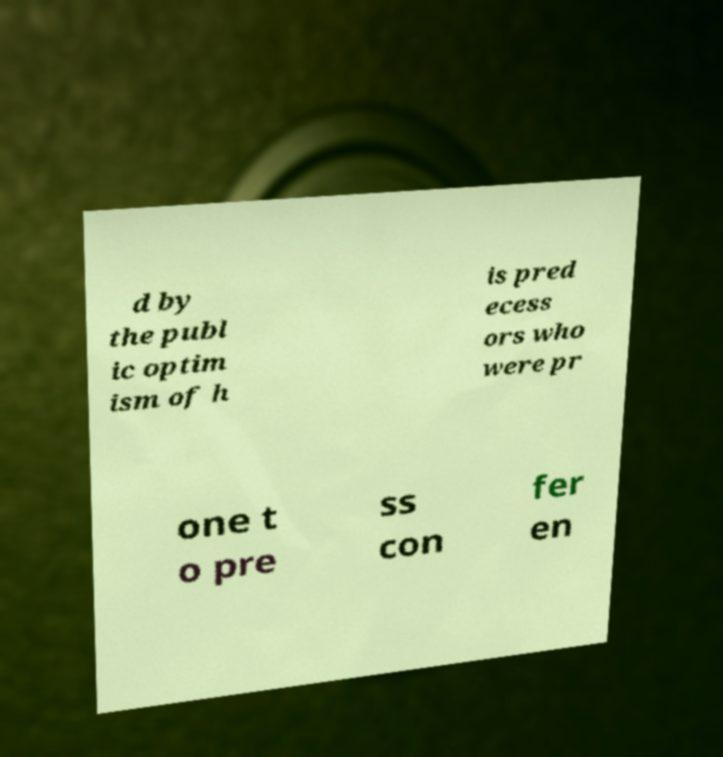I need the written content from this picture converted into text. Can you do that? d by the publ ic optim ism of h is pred ecess ors who were pr one t o pre ss con fer en 